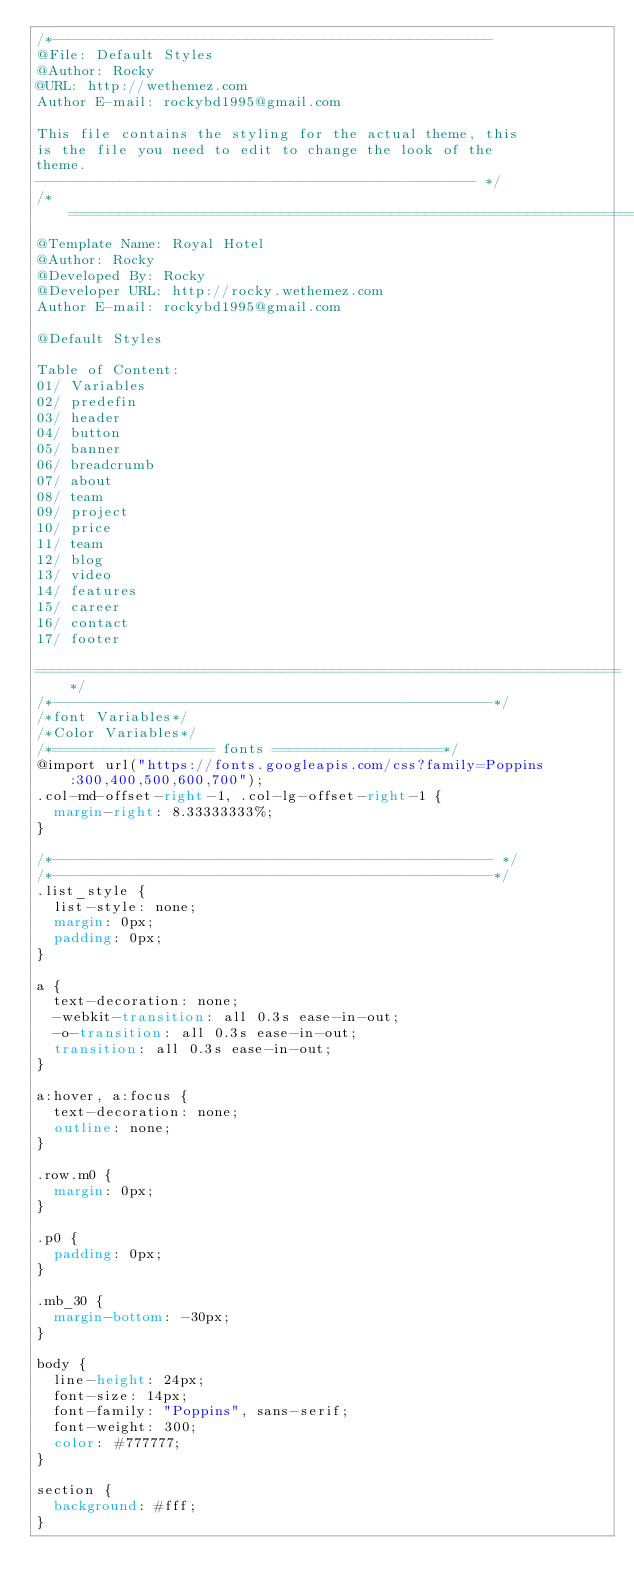Convert code to text. <code><loc_0><loc_0><loc_500><loc_500><_CSS_>/*----------------------------------------------------
@File: Default Styles
@Author: Rocky
@URL: http://wethemez.com
Author E-mail: rockybd1995@gmail.com

This file contains the styling for the actual theme, this
is the file you need to edit to change the look of the
theme.
---------------------------------------------------- */
/*=====================================================================
@Template Name: Royal Hotel
@Author: Rocky
@Developed By: Rocky
@Developer URL: http://rocky.wethemez.com
Author E-mail: rockybd1995@gmail.com

@Default Styles

Table of Content:
01/ Variables
02/ predefin
03/ header
04/ button
05/ banner
06/ breadcrumb
07/ about
08/ team
09/ project 
10/ price 
11/ team 
12/ blog 
13/ video  
14/ features  
15/ career  
16/ contact 
17/ footer

=====================================================================*/
/*----------------------------------------------------*/
/*font Variables*/
/*Color Variables*/
/*=================== fonts ====================*/
@import url("https://fonts.googleapis.com/css?family=Poppins:300,400,500,600,700");
.col-md-offset-right-1, .col-lg-offset-right-1 {
  margin-right: 8.33333333%;
}

/*---------------------------------------------------- */
/*----------------------------------------------------*/
.list_style {
  list-style: none;
  margin: 0px;
  padding: 0px;
}

a {
  text-decoration: none;
  -webkit-transition: all 0.3s ease-in-out;
  -o-transition: all 0.3s ease-in-out;
  transition: all 0.3s ease-in-out;
}

a:hover, a:focus {
  text-decoration: none;
  outline: none;
}

.row.m0 {
  margin: 0px;
}

.p0 {
  padding: 0px;
}

.mb_30 {
  margin-bottom: -30px;
}

body {
  line-height: 24px;
  font-size: 14px;
  font-family: "Poppins", sans-serif;
  font-weight: 300;
  color: #777777;
}

section {
  background: #fff;
}
</code> 